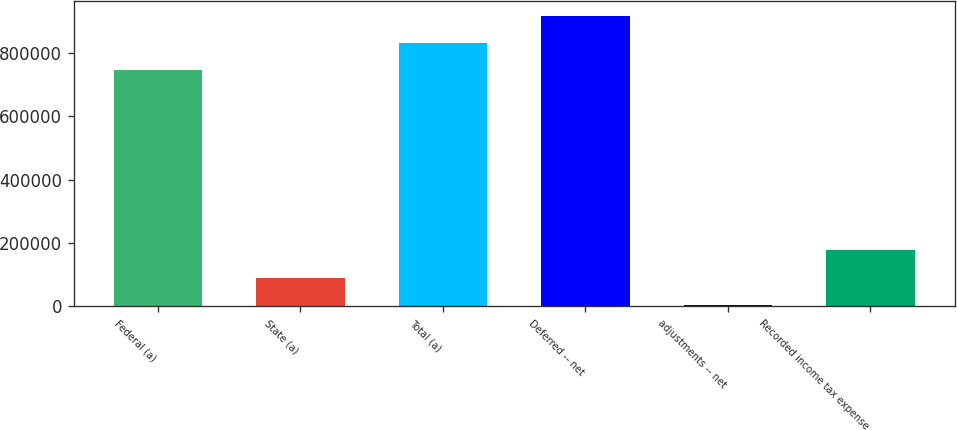Convert chart. <chart><loc_0><loc_0><loc_500><loc_500><bar_chart><fcel>Federal (a)<fcel>State (a)<fcel>Total (a)<fcel>Deferred -- net<fcel>adjustments -- net<fcel>Recorded income tax expense<nl><fcel>745724<fcel>91218.5<fcel>831662<fcel>917599<fcel>5281<fcel>177156<nl></chart> 